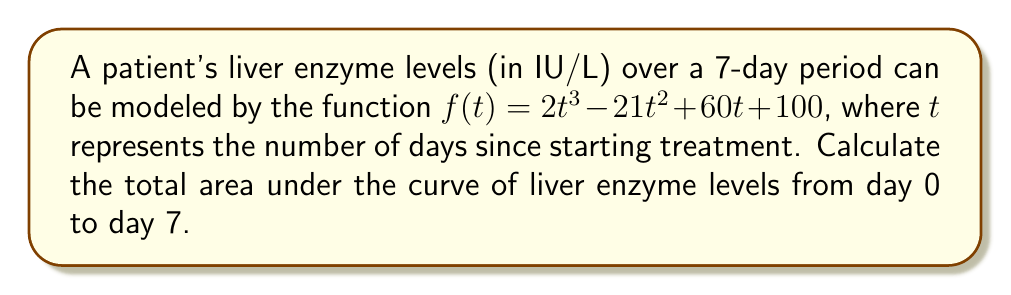Can you answer this question? To find the area under the curve, we need to calculate the definite integral of the function $f(t)$ from $t=0$ to $t=7$. Here's how we do it:

1) The integral of $f(t) = 2t^3 - 21t^2 + 60t + 100$ is:

   $$F(t) = \frac{1}{2}t^4 - 7t^3 + 30t^2 + 100t + C$$

2) Now, we need to evaluate $F(7) - F(0)$:

   $$F(7) = \frac{1}{2}(7^4) - 7(7^3) + 30(7^2) + 100(7)$$
   $$= \frac{1}{2}(2401) - 7(343) + 30(49) + 700$$
   $$= 1200.5 - 2401 + 1470 + 700 = 969.5$$

   $$F(0) = \frac{1}{2}(0^4) - 7(0^3) + 30(0^2) + 100(0) = 0$$

3) The area under the curve is:

   $$\text{Area} = F(7) - F(0) = 969.5 - 0 = 969.5$$

This represents the total accumulation of liver enzyme levels over the 7-day period.
Answer: 969.5 IU/L·days 